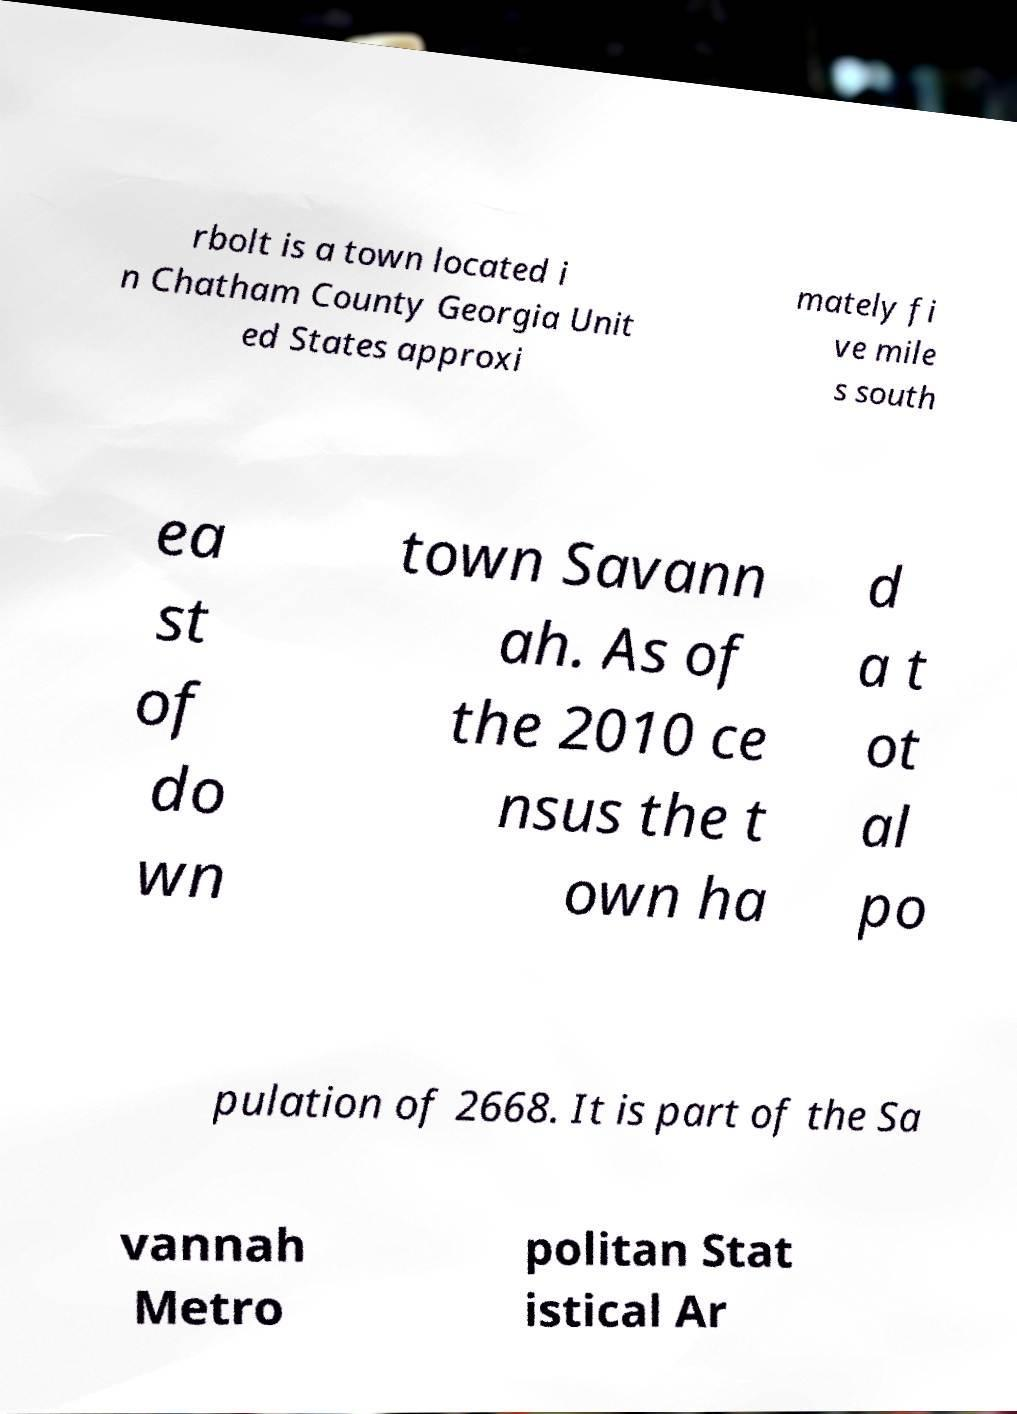What messages or text are displayed in this image? I need them in a readable, typed format. rbolt is a town located i n Chatham County Georgia Unit ed States approxi mately fi ve mile s south ea st of do wn town Savann ah. As of the 2010 ce nsus the t own ha d a t ot al po pulation of 2668. It is part of the Sa vannah Metro politan Stat istical Ar 